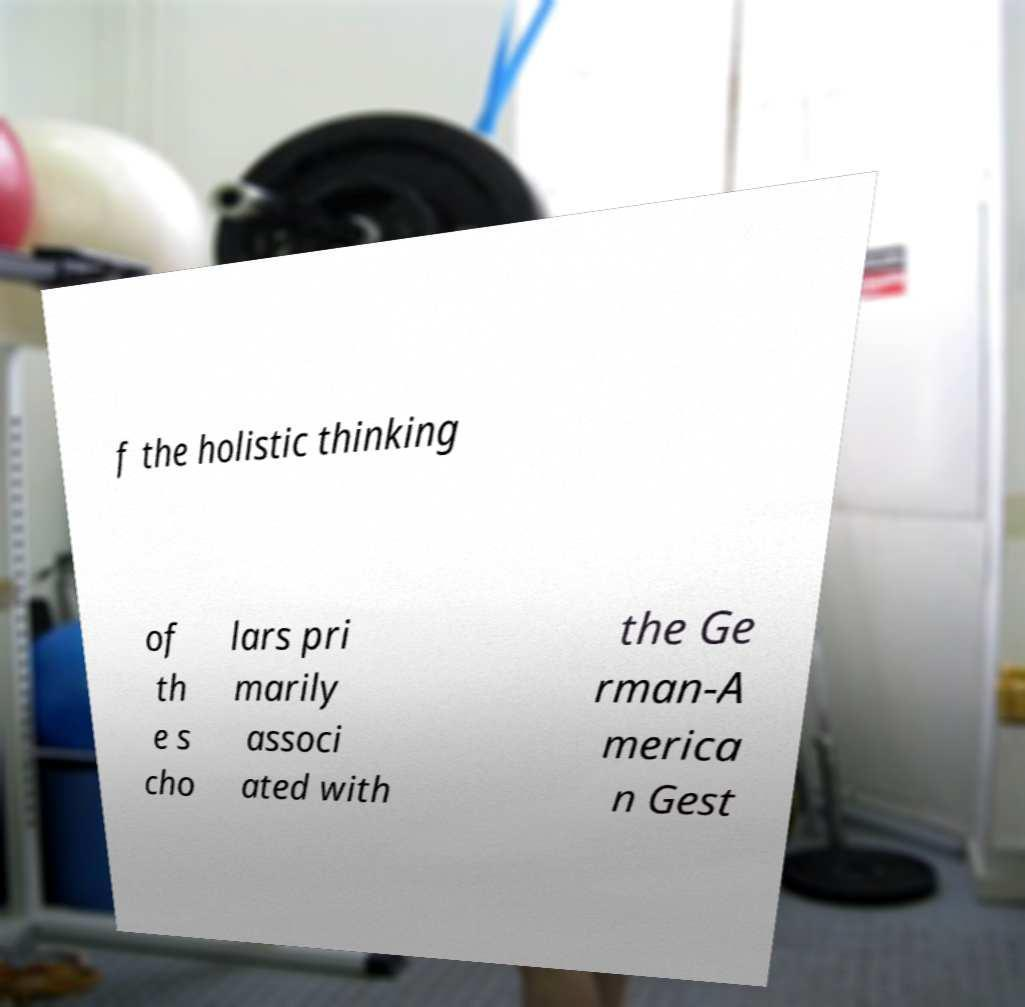What messages or text are displayed in this image? I need them in a readable, typed format. f the holistic thinking of th e s cho lars pri marily associ ated with the Ge rman-A merica n Gest 